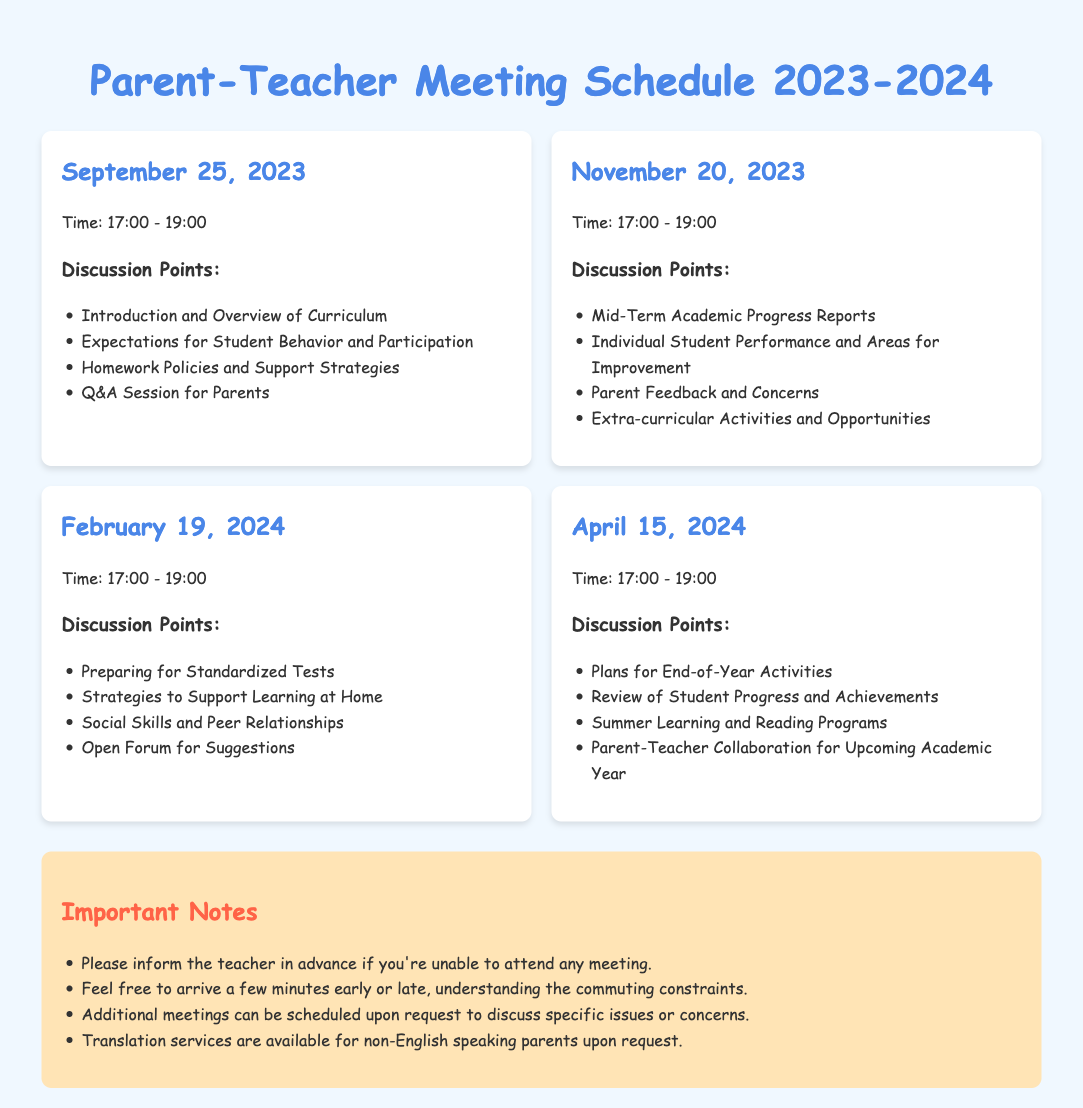What is the first meeting date? The first meeting date is listed in the document, which states September 25, 2023.
Answer: September 25, 2023 How long is each meeting scheduled to last? Each meeting is scheduled to last from 17:00 to 19:00, which is two hours.
Answer: Two hours What is a discussion point for the September meeting? The document lists several discussion points for each meeting, including "Introduction and Overview of Curriculum" for September.
Answer: Introduction and Overview of Curriculum In which month is the final meeting scheduled? According to the document, the final meeting is scheduled for April, specifically on the 15th.
Answer: April What important note is mentioned about attendance? The document includes a note regarding attendance that suggests informing the teacher in advance if unable to attend.
Answer: Inform the teacher in advance What can be requested for non-English speaking parents? The document states that translation services can be requested for non-English speaking parents.
Answer: Translation services 